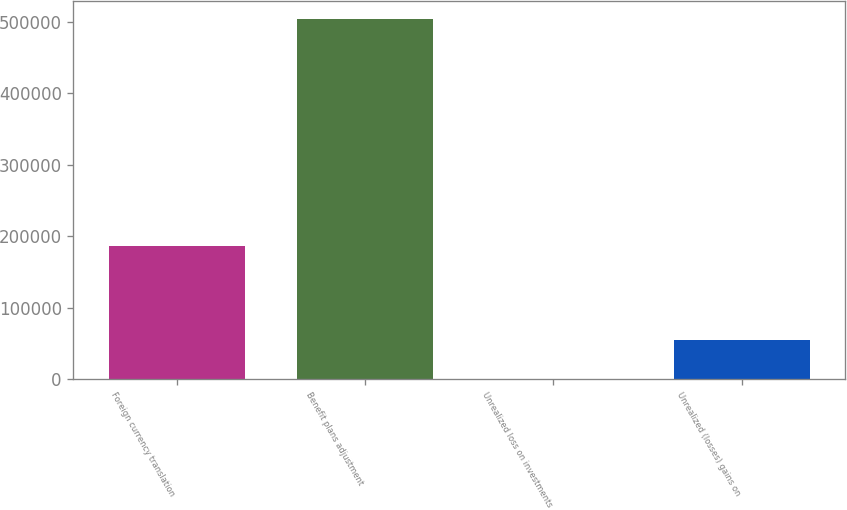<chart> <loc_0><loc_0><loc_500><loc_500><bar_chart><fcel>Foreign currency translation<fcel>Benefit plans adjustment<fcel>Unrealized loss on investments<fcel>Unrealized (losses) gains on<nl><fcel>186447<fcel>503935<fcel>581<fcel>54593<nl></chart> 